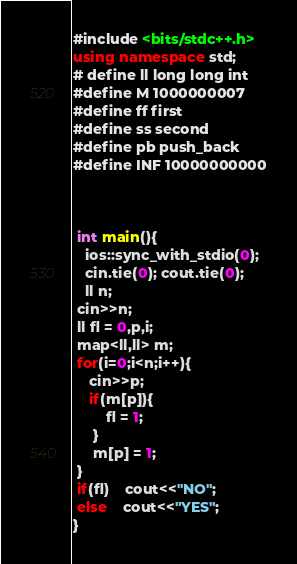<code> <loc_0><loc_0><loc_500><loc_500><_C++_>#include <bits/stdc++.h>
using namespace std;
# define ll long long int
#define M 1000000007
#define ff first
#define ss second
#define pb push_back  
#define INF 10000000000

 

 int main(){
   ios::sync_with_stdio(0);
   cin.tie(0); cout.tie(0);
   ll n;
 cin>>n;
 ll fl = 0,p,i;
 map<ll,ll> m;
 for(i=0;i<n;i++){
 	cin>>p;
 	if(m[p]){
 		fl = 1;
	 }
	 m[p] = 1;
 }
 if(fl)	cout<<"NO";
 else	cout<<"YES";
}</code> 